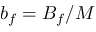<formula> <loc_0><loc_0><loc_500><loc_500>b _ { f } = B _ { f } / M</formula> 